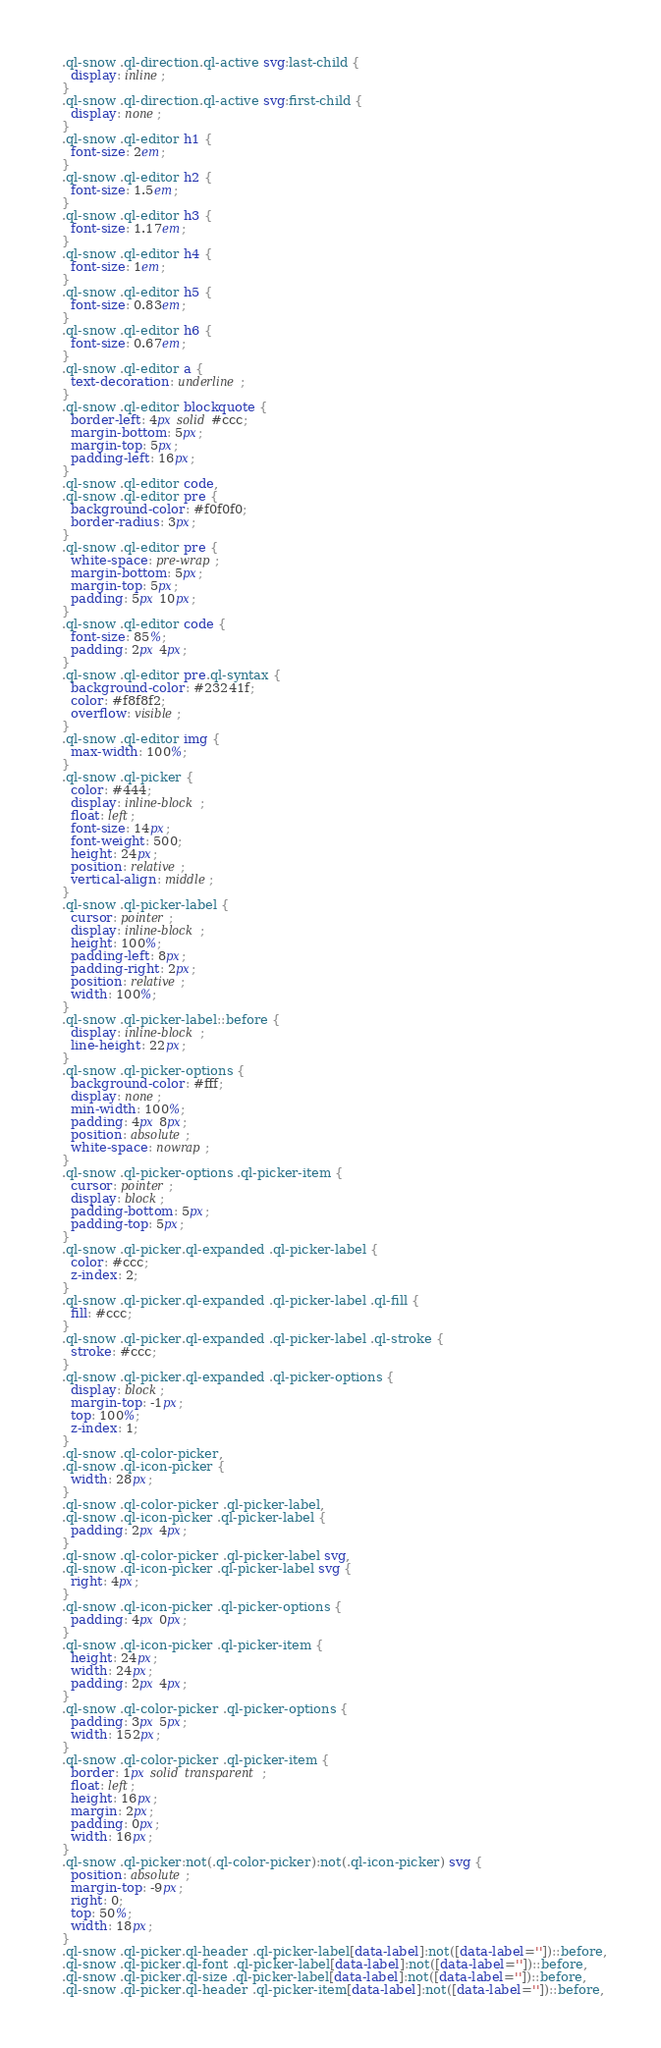<code> <loc_0><loc_0><loc_500><loc_500><_CSS_>  .ql-snow .ql-direction.ql-active svg:last-child {
    display: inline;
  }
  .ql-snow .ql-direction.ql-active svg:first-child {
    display: none;
  }
  .ql-snow .ql-editor h1 {
    font-size: 2em;
  }
  .ql-snow .ql-editor h2 {
    font-size: 1.5em;
  }
  .ql-snow .ql-editor h3 {
    font-size: 1.17em;
  }
  .ql-snow .ql-editor h4 {
    font-size: 1em;
  }
  .ql-snow .ql-editor h5 {
    font-size: 0.83em;
  }
  .ql-snow .ql-editor h6 {
    font-size: 0.67em;
  }
  .ql-snow .ql-editor a {
    text-decoration: underline;
  }
  .ql-snow .ql-editor blockquote {
    border-left: 4px solid #ccc;
    margin-bottom: 5px;
    margin-top: 5px;
    padding-left: 16px;
  }
  .ql-snow .ql-editor code,
  .ql-snow .ql-editor pre {
    background-color: #f0f0f0;
    border-radius: 3px;
  }
  .ql-snow .ql-editor pre {
    white-space: pre-wrap;
    margin-bottom: 5px;
    margin-top: 5px;
    padding: 5px 10px;
  }
  .ql-snow .ql-editor code {
    font-size: 85%;
    padding: 2px 4px;
  }
  .ql-snow .ql-editor pre.ql-syntax {
    background-color: #23241f;
    color: #f8f8f2;
    overflow: visible;
  }
  .ql-snow .ql-editor img {
    max-width: 100%;
  }
  .ql-snow .ql-picker {
    color: #444;
    display: inline-block;
    float: left;
    font-size: 14px;
    font-weight: 500;
    height: 24px;
    position: relative;
    vertical-align: middle;
  }
  .ql-snow .ql-picker-label {
    cursor: pointer;
    display: inline-block;
    height: 100%;
    padding-left: 8px;
    padding-right: 2px;
    position: relative;
    width: 100%;
  }
  .ql-snow .ql-picker-label::before {
    display: inline-block;
    line-height: 22px;
  }
  .ql-snow .ql-picker-options {
    background-color: #fff;
    display: none;
    min-width: 100%;
    padding: 4px 8px;
    position: absolute;
    white-space: nowrap;
  }
  .ql-snow .ql-picker-options .ql-picker-item {
    cursor: pointer;
    display: block;
    padding-bottom: 5px;
    padding-top: 5px;
  }
  .ql-snow .ql-picker.ql-expanded .ql-picker-label {
    color: #ccc;
    z-index: 2;
  }
  .ql-snow .ql-picker.ql-expanded .ql-picker-label .ql-fill {
    fill: #ccc;
  }
  .ql-snow .ql-picker.ql-expanded .ql-picker-label .ql-stroke {
    stroke: #ccc;
  }
  .ql-snow .ql-picker.ql-expanded .ql-picker-options {
    display: block;
    margin-top: -1px;
    top: 100%;
    z-index: 1;
  }
  .ql-snow .ql-color-picker,
  .ql-snow .ql-icon-picker {
    width: 28px;
  }
  .ql-snow .ql-color-picker .ql-picker-label,
  .ql-snow .ql-icon-picker .ql-picker-label {
    padding: 2px 4px;
  }
  .ql-snow .ql-color-picker .ql-picker-label svg,
  .ql-snow .ql-icon-picker .ql-picker-label svg {
    right: 4px;
  }
  .ql-snow .ql-icon-picker .ql-picker-options {
    padding: 4px 0px;
  }
  .ql-snow .ql-icon-picker .ql-picker-item {
    height: 24px;
    width: 24px;
    padding: 2px 4px;
  }
  .ql-snow .ql-color-picker .ql-picker-options {
    padding: 3px 5px;
    width: 152px;
  }
  .ql-snow .ql-color-picker .ql-picker-item {
    border: 1px solid transparent;
    float: left;
    height: 16px;
    margin: 2px;
    padding: 0px;
    width: 16px;
  }
  .ql-snow .ql-picker:not(.ql-color-picker):not(.ql-icon-picker) svg {
    position: absolute;
    margin-top: -9px;
    right: 0;
    top: 50%;
    width: 18px;
  }
  .ql-snow .ql-picker.ql-header .ql-picker-label[data-label]:not([data-label=''])::before,
  .ql-snow .ql-picker.ql-font .ql-picker-label[data-label]:not([data-label=''])::before,
  .ql-snow .ql-picker.ql-size .ql-picker-label[data-label]:not([data-label=''])::before,
  .ql-snow .ql-picker.ql-header .ql-picker-item[data-label]:not([data-label=''])::before,</code> 